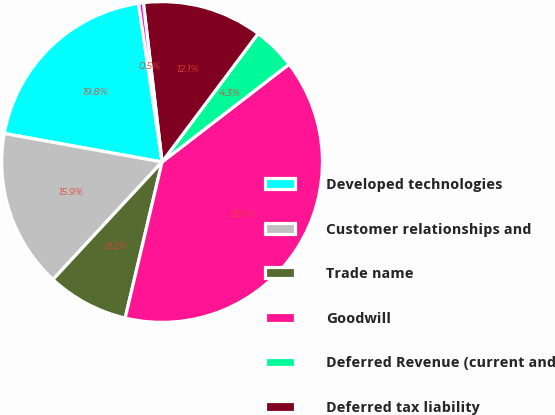Convert chart. <chart><loc_0><loc_0><loc_500><loc_500><pie_chart><fcel>Developed technologies<fcel>Customer relationships and<fcel>Trade name<fcel>Goodwill<fcel>Deferred Revenue (current and<fcel>Deferred tax liability<fcel>Net tangible assets<nl><fcel>19.81%<fcel>15.94%<fcel>8.21%<fcel>39.14%<fcel>4.34%<fcel>12.08%<fcel>0.48%<nl></chart> 